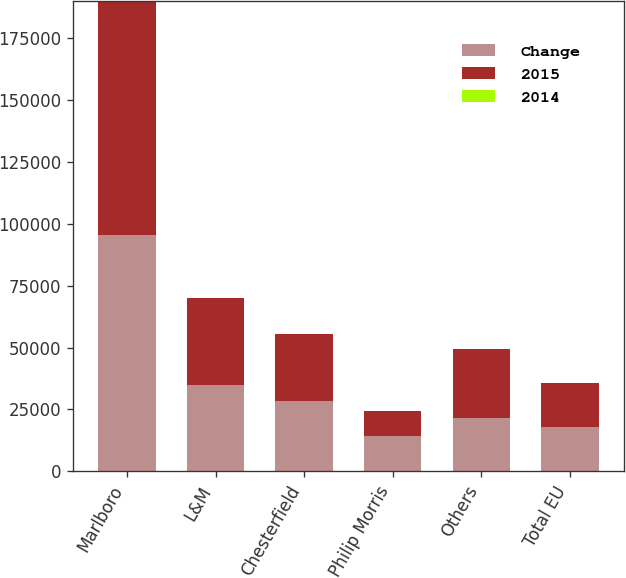<chart> <loc_0><loc_0><loc_500><loc_500><stacked_bar_chart><ecel><fcel>Marlboro<fcel>L&M<fcel>Chesterfield<fcel>Philip Morris<fcel>Others<fcel>Total EU<nl><fcel>Change<fcel>95588<fcel>35010<fcel>28278<fcel>14205<fcel>21508<fcel>17856.5<nl><fcel>2015<fcel>94537<fcel>34943<fcel>27100<fcel>10224<fcel>27942<fcel>17856.5<nl><fcel>2014<fcel>1.1<fcel>0.2<fcel>4.3<fcel>38.9<fcel>23<fcel>0.1<nl></chart> 